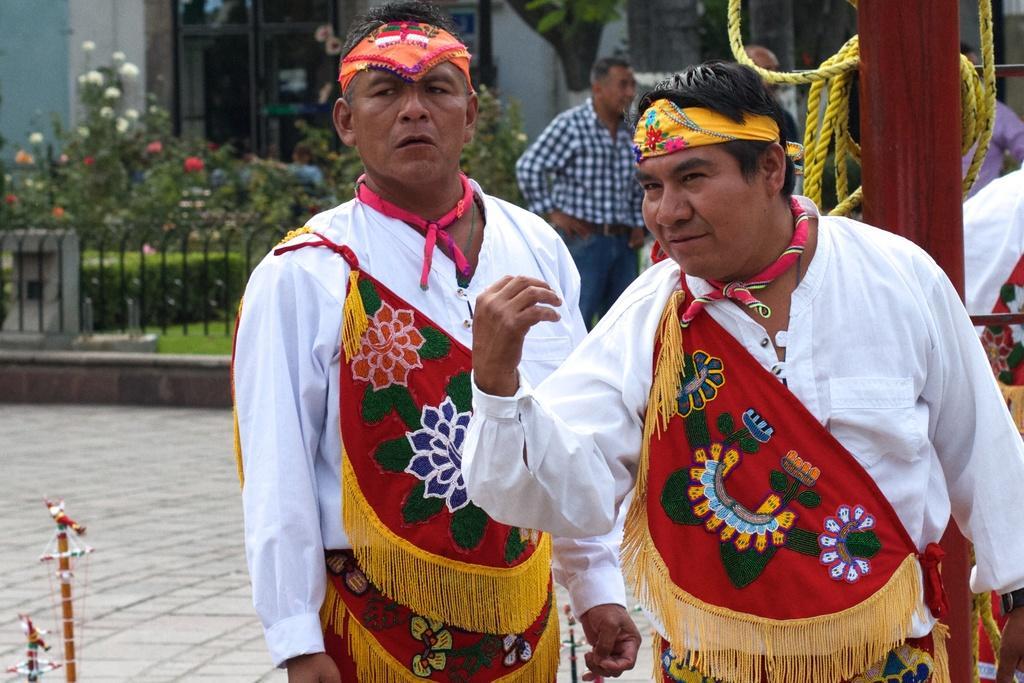How would you summarize this image in a sentence or two? There are two persons wearing a costume. In the back there is a pole and a rope. In the background there are few people, railing, grass, flowering plants and a building. 